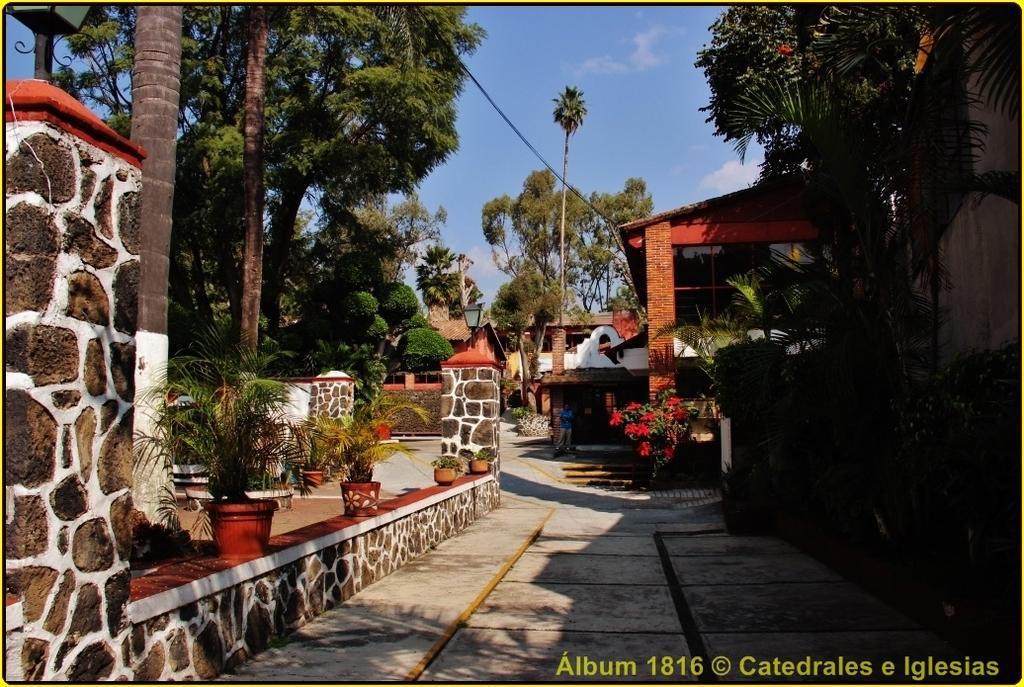In one or two sentences, can you explain what this image depicts? On the left side, there are pot plants arranged on a wall, near a road and footpath. On the right side, there is a watermark, which is near trees. In the background, there are buildings, wall, trees and clouds in the blue sky. 